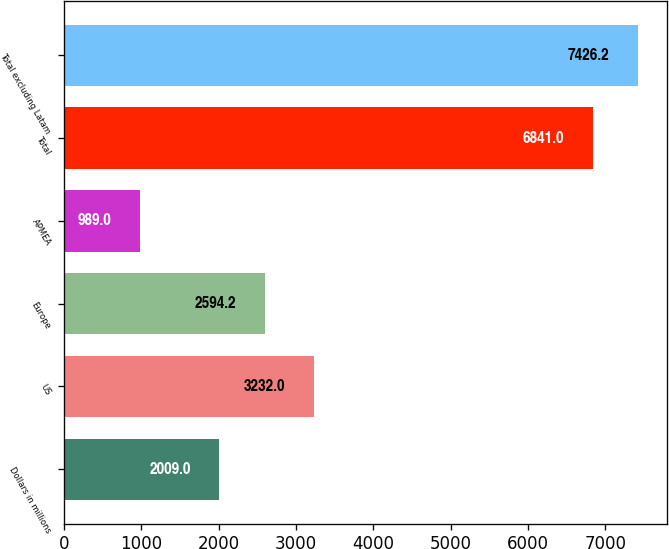Convert chart. <chart><loc_0><loc_0><loc_500><loc_500><bar_chart><fcel>Dollars in millions<fcel>US<fcel>Europe<fcel>APMEA<fcel>Total<fcel>Total excluding Latam<nl><fcel>2009<fcel>3232<fcel>2594.2<fcel>989<fcel>6841<fcel>7426.2<nl></chart> 